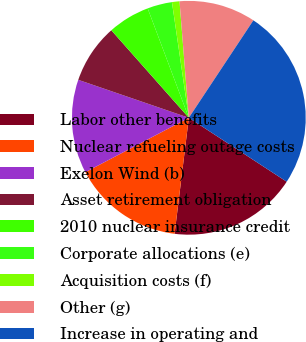<chart> <loc_0><loc_0><loc_500><loc_500><pie_chart><fcel>Labor other benefits<fcel>Nuclear refueling outage costs<fcel>Exelon Wind (b)<fcel>Asset retirement obligation<fcel>2010 nuclear insurance credit<fcel>Corporate allocations (e)<fcel>Acquisition costs (f)<fcel>Other (g)<fcel>Increase in operating and<nl><fcel>17.74%<fcel>15.35%<fcel>12.97%<fcel>8.2%<fcel>5.81%<fcel>3.42%<fcel>1.04%<fcel>10.58%<fcel>24.9%<nl></chart> 